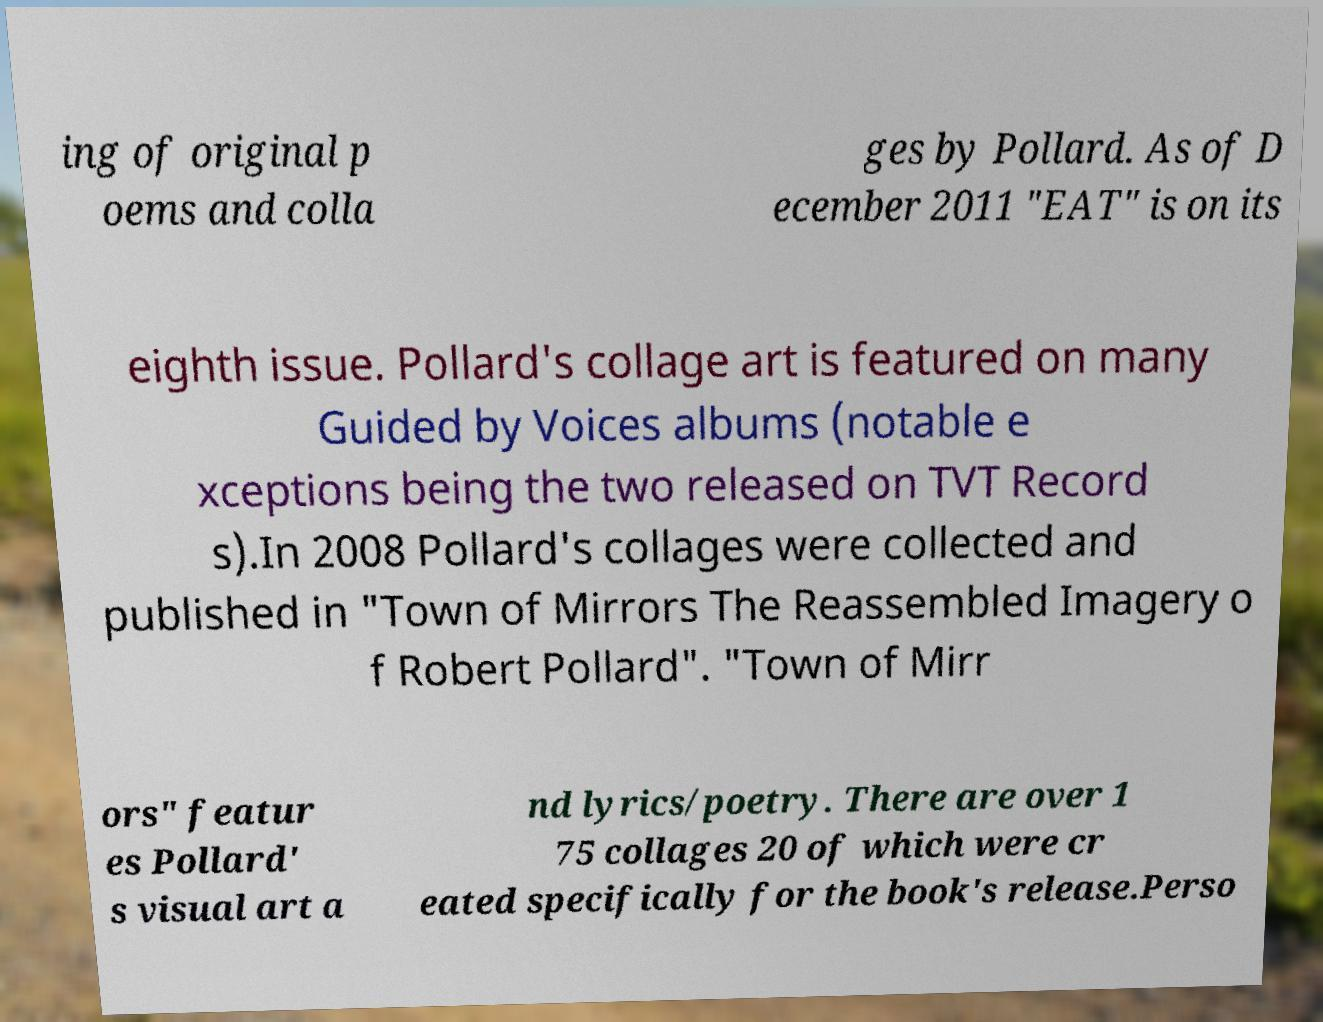Can you read and provide the text displayed in the image?This photo seems to have some interesting text. Can you extract and type it out for me? ing of original p oems and colla ges by Pollard. As of D ecember 2011 "EAT" is on its eighth issue. Pollard's collage art is featured on many Guided by Voices albums (notable e xceptions being the two released on TVT Record s).In 2008 Pollard's collages were collected and published in "Town of Mirrors The Reassembled Imagery o f Robert Pollard". "Town of Mirr ors" featur es Pollard' s visual art a nd lyrics/poetry. There are over 1 75 collages 20 of which were cr eated specifically for the book's release.Perso 